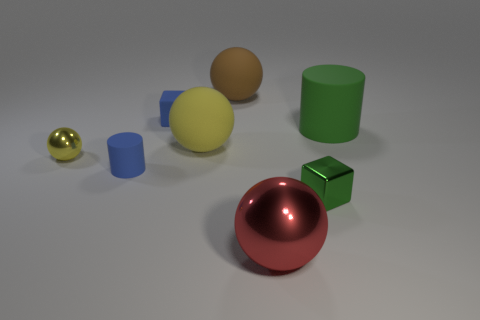Are there fewer small green things to the left of the green block than large balls?
Give a very brief answer. Yes. Are there more big red things right of the big green cylinder than metal spheres that are on the left side of the tiny yellow metal ball?
Ensure brevity in your answer.  No. Is there anything else that is the same color as the tiny metallic cube?
Keep it short and to the point. Yes. What is the block that is right of the big red metal object made of?
Keep it short and to the point. Metal. Is the green cylinder the same size as the brown object?
Ensure brevity in your answer.  Yes. How many other objects are there of the same size as the green metallic block?
Keep it short and to the point. 3. Is the large cylinder the same color as the tiny metal block?
Offer a terse response. Yes. There is a big yellow rubber object that is behind the tiny rubber thing that is in front of the small matte object behind the large cylinder; what is its shape?
Provide a short and direct response. Sphere. What number of things are shiny objects to the left of the small green metal thing or large matte objects right of the green cube?
Make the answer very short. 3. There is a red sphere that is in front of the blue matte object that is behind the big green rubber thing; what is its size?
Ensure brevity in your answer.  Large. 